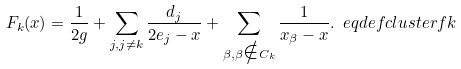<formula> <loc_0><loc_0><loc_500><loc_500>F _ { k } ( x ) = \frac { 1 } { 2 g } + \sum _ { j , j \neq k } \frac { d _ { j } } { 2 e _ { j } - x } + \sum _ { \beta , \beta \notin C _ { k } } \frac { 1 } { x _ { \beta } - x } . \ e q d e f { c l u s t e r f k }</formula> 